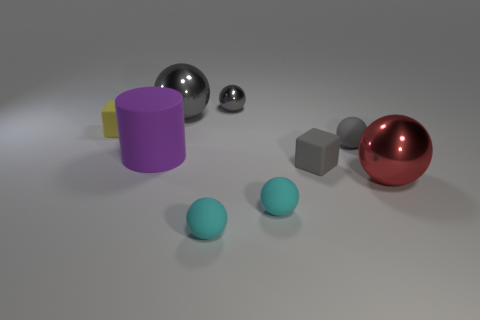Subtract all green cylinders. How many gray spheres are left? 3 Subtract 2 balls. How many balls are left? 4 Subtract all cyan spheres. How many spheres are left? 4 Subtract all cyan rubber spheres. How many spheres are left? 4 Subtract all purple balls. Subtract all cyan cylinders. How many balls are left? 6 Subtract all cubes. How many objects are left? 7 Subtract all red balls. Subtract all gray objects. How many objects are left? 4 Add 7 big gray metal balls. How many big gray metal balls are left? 8 Add 1 small green matte blocks. How many small green matte blocks exist? 1 Subtract 0 purple cubes. How many objects are left? 9 